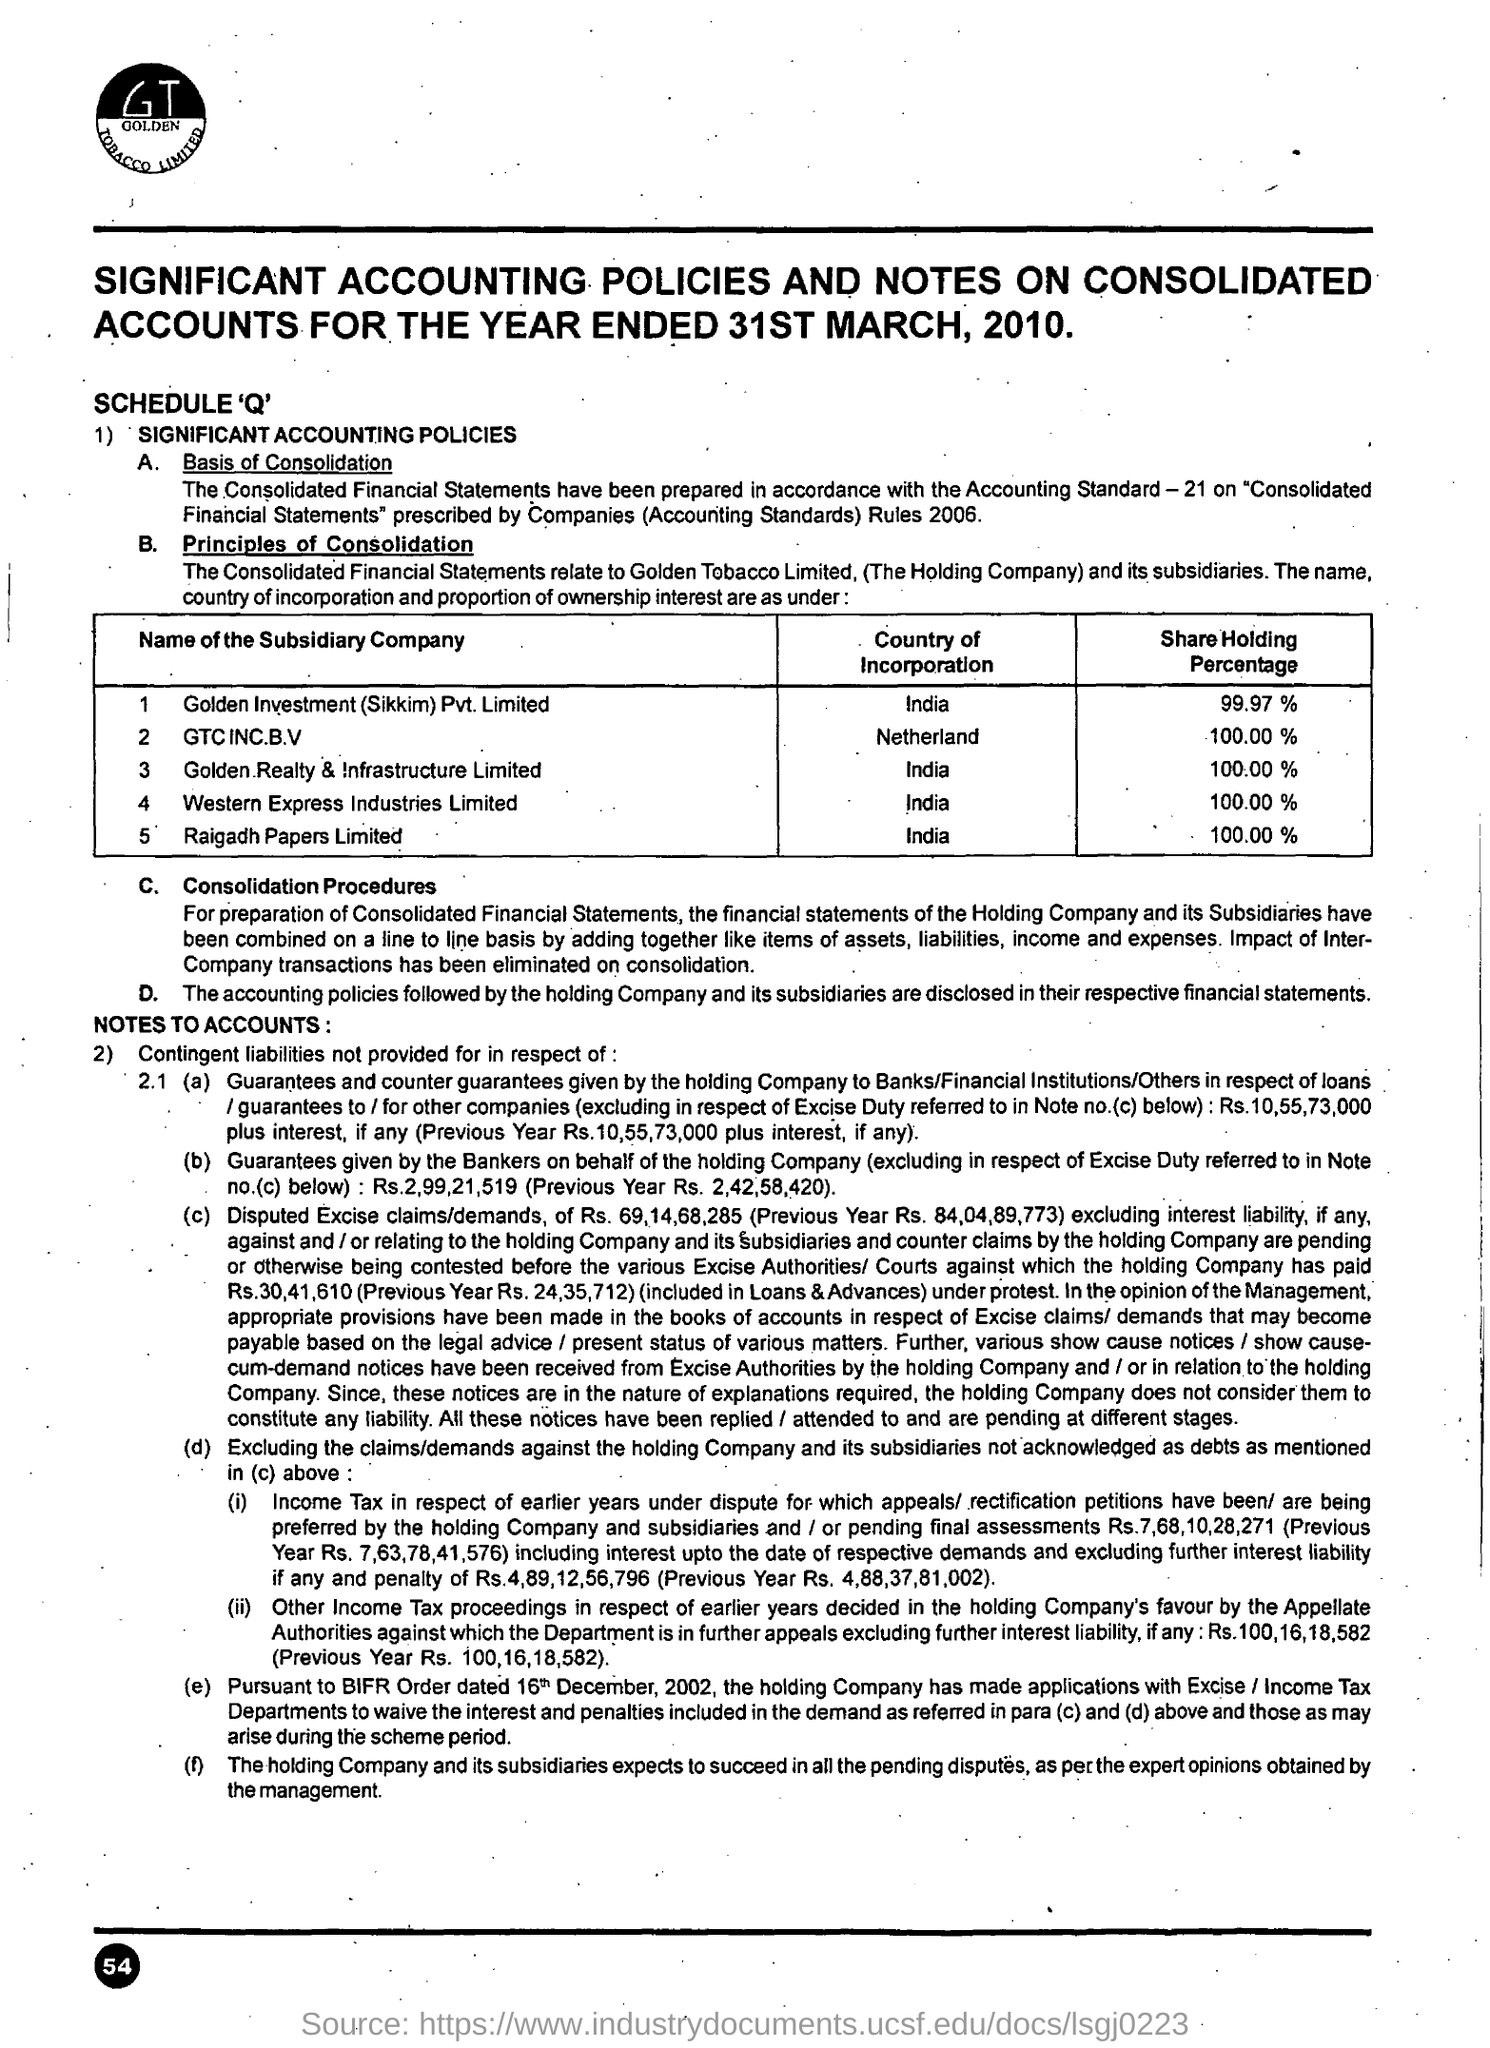Give some essential details in this illustration. India is the country that is incorporated with Raigadh Papers Limited. The share holding percentage of GTC INC B.V is 100.00% 